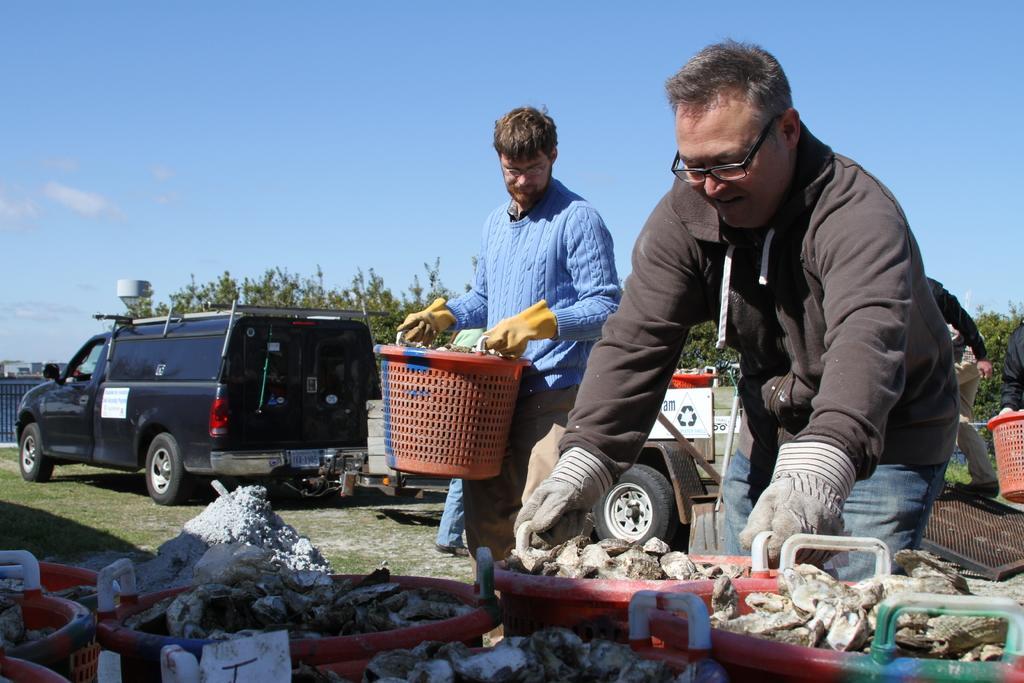How would you summarize this image in a sentence or two? In this image there is a person about to lift the plastic basket with some objects in it, in front of them there are a few other plastic baskets with objects in it, beside the person there is another person standing, holding a plastic basket with some objects in it, behind them there are cars and trucks, in the background of the image there are trees and buildings. 